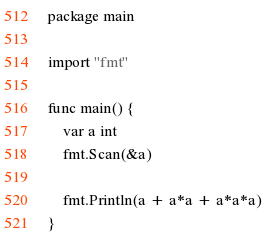<code> <loc_0><loc_0><loc_500><loc_500><_Go_>package main

import "fmt"

func main() {
	var a int
	fmt.Scan(&a)

	fmt.Println(a + a*a + a*a*a)
}
</code> 